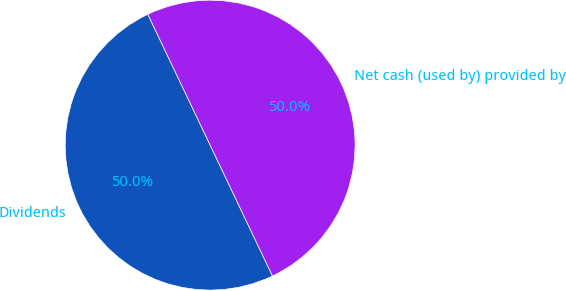Convert chart. <chart><loc_0><loc_0><loc_500><loc_500><pie_chart><fcel>Dividends<fcel>Net cash (used by) provided by<nl><fcel>50.0%<fcel>50.0%<nl></chart> 